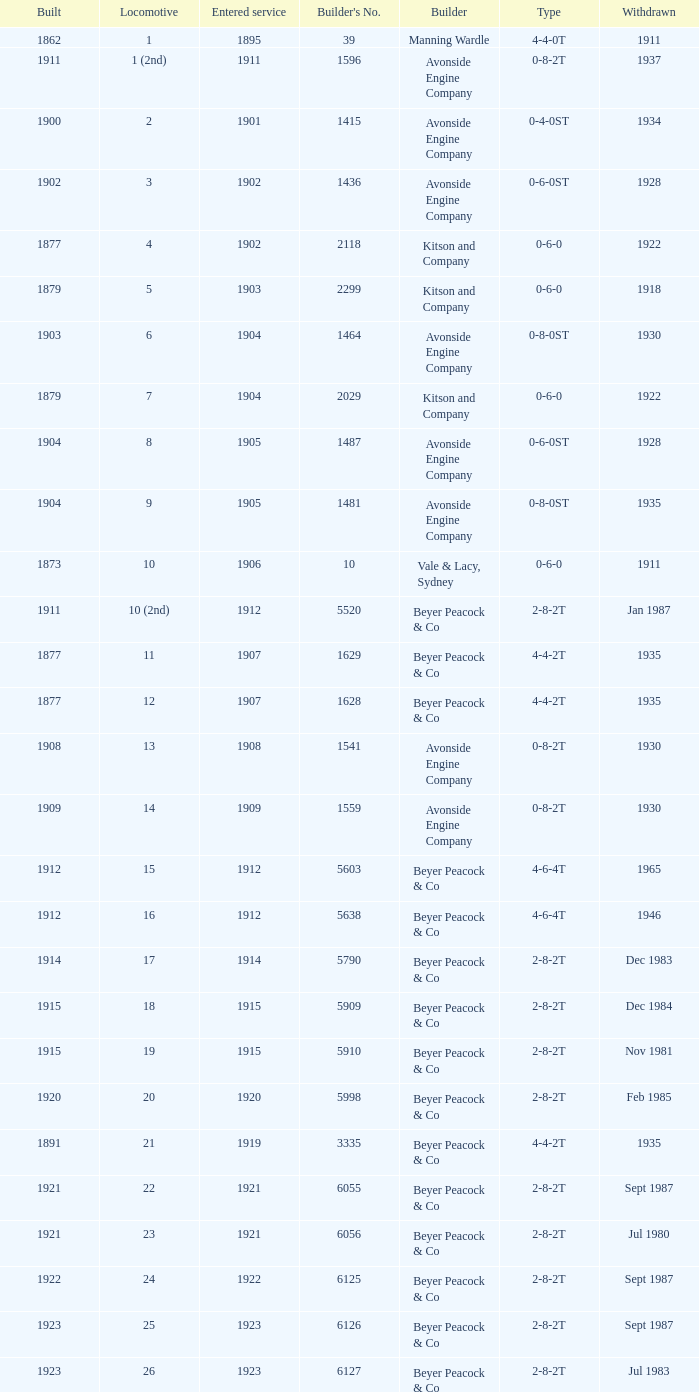Which locomotive had a 2-8-2t type, entered service year prior to 1915, and which was built after 1911? 17.0. 